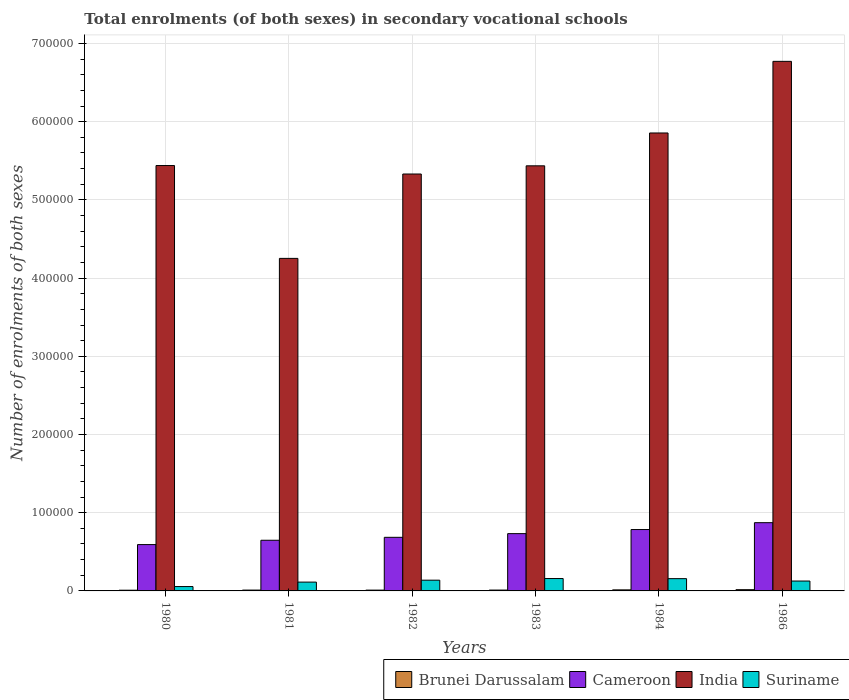How many different coloured bars are there?
Offer a very short reply. 4. Are the number of bars per tick equal to the number of legend labels?
Provide a succinct answer. Yes. How many bars are there on the 4th tick from the left?
Give a very brief answer. 4. How many bars are there on the 2nd tick from the right?
Give a very brief answer. 4. In how many cases, is the number of bars for a given year not equal to the number of legend labels?
Your answer should be very brief. 0. What is the number of enrolments in secondary schools in Suriname in 1980?
Your answer should be very brief. 5590. Across all years, what is the maximum number of enrolments in secondary schools in India?
Provide a succinct answer. 6.77e+05. Across all years, what is the minimum number of enrolments in secondary schools in India?
Provide a short and direct response. 4.25e+05. In which year was the number of enrolments in secondary schools in Suriname maximum?
Give a very brief answer. 1983. In which year was the number of enrolments in secondary schools in Suriname minimum?
Your answer should be compact. 1980. What is the total number of enrolments in secondary schools in India in the graph?
Your response must be concise. 3.31e+06. What is the difference between the number of enrolments in secondary schools in Cameroon in 1981 and that in 1986?
Offer a very short reply. -2.25e+04. What is the difference between the number of enrolments in secondary schools in Suriname in 1981 and the number of enrolments in secondary schools in Brunei Darussalam in 1980?
Provide a succinct answer. 1.04e+04. What is the average number of enrolments in secondary schools in Brunei Darussalam per year?
Make the answer very short. 1168.67. In the year 1982, what is the difference between the number of enrolments in secondary schools in Suriname and number of enrolments in secondary schools in Cameroon?
Keep it short and to the point. -5.48e+04. In how many years, is the number of enrolments in secondary schools in Cameroon greater than 680000?
Your answer should be compact. 0. What is the ratio of the number of enrolments in secondary schools in Suriname in 1980 to that in 1984?
Your response must be concise. 0.36. Is the number of enrolments in secondary schools in India in 1980 less than that in 1984?
Your answer should be very brief. Yes. What is the difference between the highest and the second highest number of enrolments in secondary schools in Cameroon?
Your response must be concise. 8786. What is the difference between the highest and the lowest number of enrolments in secondary schools in India?
Provide a succinct answer. 2.52e+05. In how many years, is the number of enrolments in secondary schools in Suriname greater than the average number of enrolments in secondary schools in Suriname taken over all years?
Offer a terse response. 4. What does the 4th bar from the left in 1981 represents?
Provide a short and direct response. Suriname. What does the 3rd bar from the right in 1981 represents?
Provide a short and direct response. Cameroon. Is it the case that in every year, the sum of the number of enrolments in secondary schools in Cameroon and number of enrolments in secondary schools in Brunei Darussalam is greater than the number of enrolments in secondary schools in India?
Your answer should be very brief. No. How many bars are there?
Offer a very short reply. 24. Are all the bars in the graph horizontal?
Offer a very short reply. No. How many years are there in the graph?
Give a very brief answer. 6. Are the values on the major ticks of Y-axis written in scientific E-notation?
Offer a terse response. No. Does the graph contain grids?
Give a very brief answer. Yes. Where does the legend appear in the graph?
Your answer should be compact. Bottom right. How many legend labels are there?
Offer a terse response. 4. What is the title of the graph?
Ensure brevity in your answer.  Total enrolments (of both sexes) in secondary vocational schools. Does "Seychelles" appear as one of the legend labels in the graph?
Your answer should be compact. No. What is the label or title of the Y-axis?
Make the answer very short. Number of enrolments of both sexes. What is the Number of enrolments of both sexes in Brunei Darussalam in 1980?
Keep it short and to the point. 909. What is the Number of enrolments of both sexes of Cameroon in 1980?
Your answer should be very brief. 5.92e+04. What is the Number of enrolments of both sexes in India in 1980?
Provide a short and direct response. 5.44e+05. What is the Number of enrolments of both sexes of Suriname in 1980?
Ensure brevity in your answer.  5590. What is the Number of enrolments of both sexes of Brunei Darussalam in 1981?
Offer a terse response. 1064. What is the Number of enrolments of both sexes of Cameroon in 1981?
Offer a very short reply. 6.48e+04. What is the Number of enrolments of both sexes in India in 1981?
Make the answer very short. 4.25e+05. What is the Number of enrolments of both sexes of Suriname in 1981?
Ensure brevity in your answer.  1.13e+04. What is the Number of enrolments of both sexes in Brunei Darussalam in 1982?
Provide a succinct answer. 1036. What is the Number of enrolments of both sexes in Cameroon in 1982?
Make the answer very short. 6.85e+04. What is the Number of enrolments of both sexes in India in 1982?
Provide a short and direct response. 5.33e+05. What is the Number of enrolments of both sexes of Suriname in 1982?
Give a very brief answer. 1.37e+04. What is the Number of enrolments of both sexes in Brunei Darussalam in 1983?
Provide a short and direct response. 1086. What is the Number of enrolments of both sexes of Cameroon in 1983?
Your response must be concise. 7.32e+04. What is the Number of enrolments of both sexes of India in 1983?
Your answer should be very brief. 5.44e+05. What is the Number of enrolments of both sexes in Suriname in 1983?
Offer a very short reply. 1.58e+04. What is the Number of enrolments of both sexes of Brunei Darussalam in 1984?
Make the answer very short. 1339. What is the Number of enrolments of both sexes of Cameroon in 1984?
Keep it short and to the point. 7.85e+04. What is the Number of enrolments of both sexes of India in 1984?
Give a very brief answer. 5.86e+05. What is the Number of enrolments of both sexes of Suriname in 1984?
Your answer should be compact. 1.57e+04. What is the Number of enrolments of both sexes of Brunei Darussalam in 1986?
Give a very brief answer. 1578. What is the Number of enrolments of both sexes in Cameroon in 1986?
Your response must be concise. 8.73e+04. What is the Number of enrolments of both sexes of India in 1986?
Keep it short and to the point. 6.77e+05. What is the Number of enrolments of both sexes of Suriname in 1986?
Provide a succinct answer. 1.26e+04. Across all years, what is the maximum Number of enrolments of both sexes in Brunei Darussalam?
Offer a very short reply. 1578. Across all years, what is the maximum Number of enrolments of both sexes of Cameroon?
Give a very brief answer. 8.73e+04. Across all years, what is the maximum Number of enrolments of both sexes of India?
Keep it short and to the point. 6.77e+05. Across all years, what is the maximum Number of enrolments of both sexes in Suriname?
Provide a succinct answer. 1.58e+04. Across all years, what is the minimum Number of enrolments of both sexes in Brunei Darussalam?
Provide a succinct answer. 909. Across all years, what is the minimum Number of enrolments of both sexes of Cameroon?
Provide a succinct answer. 5.92e+04. Across all years, what is the minimum Number of enrolments of both sexes of India?
Provide a short and direct response. 4.25e+05. Across all years, what is the minimum Number of enrolments of both sexes in Suriname?
Ensure brevity in your answer.  5590. What is the total Number of enrolments of both sexes of Brunei Darussalam in the graph?
Provide a short and direct response. 7012. What is the total Number of enrolments of both sexes in Cameroon in the graph?
Offer a terse response. 4.32e+05. What is the total Number of enrolments of both sexes in India in the graph?
Offer a terse response. 3.31e+06. What is the total Number of enrolments of both sexes in Suriname in the graph?
Provide a succinct answer. 7.48e+04. What is the difference between the Number of enrolments of both sexes in Brunei Darussalam in 1980 and that in 1981?
Your answer should be compact. -155. What is the difference between the Number of enrolments of both sexes in Cameroon in 1980 and that in 1981?
Make the answer very short. -5550. What is the difference between the Number of enrolments of both sexes of India in 1980 and that in 1981?
Keep it short and to the point. 1.19e+05. What is the difference between the Number of enrolments of both sexes in Suriname in 1980 and that in 1981?
Ensure brevity in your answer.  -5690. What is the difference between the Number of enrolments of both sexes in Brunei Darussalam in 1980 and that in 1982?
Offer a terse response. -127. What is the difference between the Number of enrolments of both sexes in Cameroon in 1980 and that in 1982?
Give a very brief answer. -9296. What is the difference between the Number of enrolments of both sexes in India in 1980 and that in 1982?
Make the answer very short. 1.08e+04. What is the difference between the Number of enrolments of both sexes in Suriname in 1980 and that in 1982?
Your response must be concise. -8151. What is the difference between the Number of enrolments of both sexes of Brunei Darussalam in 1980 and that in 1983?
Keep it short and to the point. -177. What is the difference between the Number of enrolments of both sexes of Cameroon in 1980 and that in 1983?
Offer a very short reply. -1.40e+04. What is the difference between the Number of enrolments of both sexes in India in 1980 and that in 1983?
Make the answer very short. 360. What is the difference between the Number of enrolments of both sexes of Suriname in 1980 and that in 1983?
Provide a short and direct response. -1.02e+04. What is the difference between the Number of enrolments of both sexes of Brunei Darussalam in 1980 and that in 1984?
Offer a terse response. -430. What is the difference between the Number of enrolments of both sexes of Cameroon in 1980 and that in 1984?
Make the answer very short. -1.92e+04. What is the difference between the Number of enrolments of both sexes in India in 1980 and that in 1984?
Offer a very short reply. -4.16e+04. What is the difference between the Number of enrolments of both sexes of Suriname in 1980 and that in 1984?
Your response must be concise. -1.01e+04. What is the difference between the Number of enrolments of both sexes in Brunei Darussalam in 1980 and that in 1986?
Provide a short and direct response. -669. What is the difference between the Number of enrolments of both sexes in Cameroon in 1980 and that in 1986?
Ensure brevity in your answer.  -2.80e+04. What is the difference between the Number of enrolments of both sexes in India in 1980 and that in 1986?
Offer a very short reply. -1.33e+05. What is the difference between the Number of enrolments of both sexes of Suriname in 1980 and that in 1986?
Offer a very short reply. -7044. What is the difference between the Number of enrolments of both sexes in Brunei Darussalam in 1981 and that in 1982?
Keep it short and to the point. 28. What is the difference between the Number of enrolments of both sexes of Cameroon in 1981 and that in 1982?
Your answer should be compact. -3746. What is the difference between the Number of enrolments of both sexes in India in 1981 and that in 1982?
Your answer should be compact. -1.08e+05. What is the difference between the Number of enrolments of both sexes of Suriname in 1981 and that in 1982?
Your answer should be compact. -2461. What is the difference between the Number of enrolments of both sexes of Brunei Darussalam in 1981 and that in 1983?
Keep it short and to the point. -22. What is the difference between the Number of enrolments of both sexes of Cameroon in 1981 and that in 1983?
Your answer should be very brief. -8456. What is the difference between the Number of enrolments of both sexes of India in 1981 and that in 1983?
Keep it short and to the point. -1.18e+05. What is the difference between the Number of enrolments of both sexes in Suriname in 1981 and that in 1983?
Ensure brevity in your answer.  -4551. What is the difference between the Number of enrolments of both sexes in Brunei Darussalam in 1981 and that in 1984?
Make the answer very short. -275. What is the difference between the Number of enrolments of both sexes of Cameroon in 1981 and that in 1984?
Your response must be concise. -1.37e+04. What is the difference between the Number of enrolments of both sexes in India in 1981 and that in 1984?
Give a very brief answer. -1.60e+05. What is the difference between the Number of enrolments of both sexes of Suriname in 1981 and that in 1984?
Keep it short and to the point. -4419. What is the difference between the Number of enrolments of both sexes of Brunei Darussalam in 1981 and that in 1986?
Keep it short and to the point. -514. What is the difference between the Number of enrolments of both sexes in Cameroon in 1981 and that in 1986?
Offer a terse response. -2.25e+04. What is the difference between the Number of enrolments of both sexes of India in 1981 and that in 1986?
Provide a short and direct response. -2.52e+05. What is the difference between the Number of enrolments of both sexes of Suriname in 1981 and that in 1986?
Keep it short and to the point. -1354. What is the difference between the Number of enrolments of both sexes in Brunei Darussalam in 1982 and that in 1983?
Ensure brevity in your answer.  -50. What is the difference between the Number of enrolments of both sexes in Cameroon in 1982 and that in 1983?
Your answer should be very brief. -4710. What is the difference between the Number of enrolments of both sexes of India in 1982 and that in 1983?
Ensure brevity in your answer.  -1.05e+04. What is the difference between the Number of enrolments of both sexes of Suriname in 1982 and that in 1983?
Provide a short and direct response. -2090. What is the difference between the Number of enrolments of both sexes in Brunei Darussalam in 1982 and that in 1984?
Make the answer very short. -303. What is the difference between the Number of enrolments of both sexes in Cameroon in 1982 and that in 1984?
Give a very brief answer. -9943. What is the difference between the Number of enrolments of both sexes of India in 1982 and that in 1984?
Provide a short and direct response. -5.25e+04. What is the difference between the Number of enrolments of both sexes in Suriname in 1982 and that in 1984?
Offer a terse response. -1958. What is the difference between the Number of enrolments of both sexes of Brunei Darussalam in 1982 and that in 1986?
Give a very brief answer. -542. What is the difference between the Number of enrolments of both sexes of Cameroon in 1982 and that in 1986?
Give a very brief answer. -1.87e+04. What is the difference between the Number of enrolments of both sexes in India in 1982 and that in 1986?
Offer a very short reply. -1.44e+05. What is the difference between the Number of enrolments of both sexes in Suriname in 1982 and that in 1986?
Ensure brevity in your answer.  1107. What is the difference between the Number of enrolments of both sexes in Brunei Darussalam in 1983 and that in 1984?
Provide a succinct answer. -253. What is the difference between the Number of enrolments of both sexes of Cameroon in 1983 and that in 1984?
Offer a terse response. -5233. What is the difference between the Number of enrolments of both sexes of India in 1983 and that in 1984?
Offer a very short reply. -4.20e+04. What is the difference between the Number of enrolments of both sexes of Suriname in 1983 and that in 1984?
Ensure brevity in your answer.  132. What is the difference between the Number of enrolments of both sexes in Brunei Darussalam in 1983 and that in 1986?
Your response must be concise. -492. What is the difference between the Number of enrolments of both sexes in Cameroon in 1983 and that in 1986?
Make the answer very short. -1.40e+04. What is the difference between the Number of enrolments of both sexes in India in 1983 and that in 1986?
Offer a terse response. -1.34e+05. What is the difference between the Number of enrolments of both sexes of Suriname in 1983 and that in 1986?
Make the answer very short. 3197. What is the difference between the Number of enrolments of both sexes of Brunei Darussalam in 1984 and that in 1986?
Provide a succinct answer. -239. What is the difference between the Number of enrolments of both sexes in Cameroon in 1984 and that in 1986?
Your answer should be very brief. -8786. What is the difference between the Number of enrolments of both sexes in India in 1984 and that in 1986?
Provide a succinct answer. -9.16e+04. What is the difference between the Number of enrolments of both sexes in Suriname in 1984 and that in 1986?
Provide a succinct answer. 3065. What is the difference between the Number of enrolments of both sexes of Brunei Darussalam in 1980 and the Number of enrolments of both sexes of Cameroon in 1981?
Keep it short and to the point. -6.39e+04. What is the difference between the Number of enrolments of both sexes of Brunei Darussalam in 1980 and the Number of enrolments of both sexes of India in 1981?
Provide a succinct answer. -4.24e+05. What is the difference between the Number of enrolments of both sexes of Brunei Darussalam in 1980 and the Number of enrolments of both sexes of Suriname in 1981?
Keep it short and to the point. -1.04e+04. What is the difference between the Number of enrolments of both sexes in Cameroon in 1980 and the Number of enrolments of both sexes in India in 1981?
Provide a short and direct response. -3.66e+05. What is the difference between the Number of enrolments of both sexes of Cameroon in 1980 and the Number of enrolments of both sexes of Suriname in 1981?
Your response must be concise. 4.80e+04. What is the difference between the Number of enrolments of both sexes in India in 1980 and the Number of enrolments of both sexes in Suriname in 1981?
Offer a very short reply. 5.33e+05. What is the difference between the Number of enrolments of both sexes in Brunei Darussalam in 1980 and the Number of enrolments of both sexes in Cameroon in 1982?
Provide a short and direct response. -6.76e+04. What is the difference between the Number of enrolments of both sexes of Brunei Darussalam in 1980 and the Number of enrolments of both sexes of India in 1982?
Make the answer very short. -5.32e+05. What is the difference between the Number of enrolments of both sexes in Brunei Darussalam in 1980 and the Number of enrolments of both sexes in Suriname in 1982?
Ensure brevity in your answer.  -1.28e+04. What is the difference between the Number of enrolments of both sexes of Cameroon in 1980 and the Number of enrolments of both sexes of India in 1982?
Ensure brevity in your answer.  -4.74e+05. What is the difference between the Number of enrolments of both sexes of Cameroon in 1980 and the Number of enrolments of both sexes of Suriname in 1982?
Keep it short and to the point. 4.55e+04. What is the difference between the Number of enrolments of both sexes in India in 1980 and the Number of enrolments of both sexes in Suriname in 1982?
Give a very brief answer. 5.30e+05. What is the difference between the Number of enrolments of both sexes of Brunei Darussalam in 1980 and the Number of enrolments of both sexes of Cameroon in 1983?
Make the answer very short. -7.23e+04. What is the difference between the Number of enrolments of both sexes in Brunei Darussalam in 1980 and the Number of enrolments of both sexes in India in 1983?
Offer a terse response. -5.43e+05. What is the difference between the Number of enrolments of both sexes of Brunei Darussalam in 1980 and the Number of enrolments of both sexes of Suriname in 1983?
Provide a succinct answer. -1.49e+04. What is the difference between the Number of enrolments of both sexes of Cameroon in 1980 and the Number of enrolments of both sexes of India in 1983?
Your response must be concise. -4.84e+05. What is the difference between the Number of enrolments of both sexes of Cameroon in 1980 and the Number of enrolments of both sexes of Suriname in 1983?
Provide a short and direct response. 4.34e+04. What is the difference between the Number of enrolments of both sexes of India in 1980 and the Number of enrolments of both sexes of Suriname in 1983?
Offer a terse response. 5.28e+05. What is the difference between the Number of enrolments of both sexes of Brunei Darussalam in 1980 and the Number of enrolments of both sexes of Cameroon in 1984?
Give a very brief answer. -7.76e+04. What is the difference between the Number of enrolments of both sexes of Brunei Darussalam in 1980 and the Number of enrolments of both sexes of India in 1984?
Provide a succinct answer. -5.85e+05. What is the difference between the Number of enrolments of both sexes in Brunei Darussalam in 1980 and the Number of enrolments of both sexes in Suriname in 1984?
Provide a short and direct response. -1.48e+04. What is the difference between the Number of enrolments of both sexes in Cameroon in 1980 and the Number of enrolments of both sexes in India in 1984?
Give a very brief answer. -5.26e+05. What is the difference between the Number of enrolments of both sexes of Cameroon in 1980 and the Number of enrolments of both sexes of Suriname in 1984?
Keep it short and to the point. 4.35e+04. What is the difference between the Number of enrolments of both sexes in India in 1980 and the Number of enrolments of both sexes in Suriname in 1984?
Make the answer very short. 5.28e+05. What is the difference between the Number of enrolments of both sexes of Brunei Darussalam in 1980 and the Number of enrolments of both sexes of Cameroon in 1986?
Your answer should be compact. -8.64e+04. What is the difference between the Number of enrolments of both sexes of Brunei Darussalam in 1980 and the Number of enrolments of both sexes of India in 1986?
Your answer should be very brief. -6.76e+05. What is the difference between the Number of enrolments of both sexes of Brunei Darussalam in 1980 and the Number of enrolments of both sexes of Suriname in 1986?
Your response must be concise. -1.17e+04. What is the difference between the Number of enrolments of both sexes of Cameroon in 1980 and the Number of enrolments of both sexes of India in 1986?
Provide a succinct answer. -6.18e+05. What is the difference between the Number of enrolments of both sexes in Cameroon in 1980 and the Number of enrolments of both sexes in Suriname in 1986?
Give a very brief answer. 4.66e+04. What is the difference between the Number of enrolments of both sexes in India in 1980 and the Number of enrolments of both sexes in Suriname in 1986?
Your response must be concise. 5.31e+05. What is the difference between the Number of enrolments of both sexes in Brunei Darussalam in 1981 and the Number of enrolments of both sexes in Cameroon in 1982?
Provide a short and direct response. -6.75e+04. What is the difference between the Number of enrolments of both sexes in Brunei Darussalam in 1981 and the Number of enrolments of both sexes in India in 1982?
Ensure brevity in your answer.  -5.32e+05. What is the difference between the Number of enrolments of both sexes of Brunei Darussalam in 1981 and the Number of enrolments of both sexes of Suriname in 1982?
Keep it short and to the point. -1.27e+04. What is the difference between the Number of enrolments of both sexes of Cameroon in 1981 and the Number of enrolments of both sexes of India in 1982?
Offer a terse response. -4.68e+05. What is the difference between the Number of enrolments of both sexes in Cameroon in 1981 and the Number of enrolments of both sexes in Suriname in 1982?
Ensure brevity in your answer.  5.11e+04. What is the difference between the Number of enrolments of both sexes in India in 1981 and the Number of enrolments of both sexes in Suriname in 1982?
Your answer should be compact. 4.11e+05. What is the difference between the Number of enrolments of both sexes in Brunei Darussalam in 1981 and the Number of enrolments of both sexes in Cameroon in 1983?
Offer a terse response. -7.22e+04. What is the difference between the Number of enrolments of both sexes in Brunei Darussalam in 1981 and the Number of enrolments of both sexes in India in 1983?
Your answer should be very brief. -5.43e+05. What is the difference between the Number of enrolments of both sexes in Brunei Darussalam in 1981 and the Number of enrolments of both sexes in Suriname in 1983?
Provide a succinct answer. -1.48e+04. What is the difference between the Number of enrolments of both sexes of Cameroon in 1981 and the Number of enrolments of both sexes of India in 1983?
Your answer should be very brief. -4.79e+05. What is the difference between the Number of enrolments of both sexes in Cameroon in 1981 and the Number of enrolments of both sexes in Suriname in 1983?
Make the answer very short. 4.90e+04. What is the difference between the Number of enrolments of both sexes in India in 1981 and the Number of enrolments of both sexes in Suriname in 1983?
Ensure brevity in your answer.  4.09e+05. What is the difference between the Number of enrolments of both sexes in Brunei Darussalam in 1981 and the Number of enrolments of both sexes in Cameroon in 1984?
Offer a terse response. -7.74e+04. What is the difference between the Number of enrolments of both sexes in Brunei Darussalam in 1981 and the Number of enrolments of both sexes in India in 1984?
Your response must be concise. -5.85e+05. What is the difference between the Number of enrolments of both sexes in Brunei Darussalam in 1981 and the Number of enrolments of both sexes in Suriname in 1984?
Offer a terse response. -1.46e+04. What is the difference between the Number of enrolments of both sexes in Cameroon in 1981 and the Number of enrolments of both sexes in India in 1984?
Your response must be concise. -5.21e+05. What is the difference between the Number of enrolments of both sexes of Cameroon in 1981 and the Number of enrolments of both sexes of Suriname in 1984?
Your answer should be very brief. 4.91e+04. What is the difference between the Number of enrolments of both sexes of India in 1981 and the Number of enrolments of both sexes of Suriname in 1984?
Your response must be concise. 4.10e+05. What is the difference between the Number of enrolments of both sexes of Brunei Darussalam in 1981 and the Number of enrolments of both sexes of Cameroon in 1986?
Keep it short and to the point. -8.62e+04. What is the difference between the Number of enrolments of both sexes of Brunei Darussalam in 1981 and the Number of enrolments of both sexes of India in 1986?
Keep it short and to the point. -6.76e+05. What is the difference between the Number of enrolments of both sexes of Brunei Darussalam in 1981 and the Number of enrolments of both sexes of Suriname in 1986?
Make the answer very short. -1.16e+04. What is the difference between the Number of enrolments of both sexes in Cameroon in 1981 and the Number of enrolments of both sexes in India in 1986?
Give a very brief answer. -6.12e+05. What is the difference between the Number of enrolments of both sexes in Cameroon in 1981 and the Number of enrolments of both sexes in Suriname in 1986?
Your response must be concise. 5.22e+04. What is the difference between the Number of enrolments of both sexes in India in 1981 and the Number of enrolments of both sexes in Suriname in 1986?
Make the answer very short. 4.13e+05. What is the difference between the Number of enrolments of both sexes of Brunei Darussalam in 1982 and the Number of enrolments of both sexes of Cameroon in 1983?
Keep it short and to the point. -7.22e+04. What is the difference between the Number of enrolments of both sexes in Brunei Darussalam in 1982 and the Number of enrolments of both sexes in India in 1983?
Keep it short and to the point. -5.43e+05. What is the difference between the Number of enrolments of both sexes of Brunei Darussalam in 1982 and the Number of enrolments of both sexes of Suriname in 1983?
Provide a short and direct response. -1.48e+04. What is the difference between the Number of enrolments of both sexes in Cameroon in 1982 and the Number of enrolments of both sexes in India in 1983?
Keep it short and to the point. -4.75e+05. What is the difference between the Number of enrolments of both sexes in Cameroon in 1982 and the Number of enrolments of both sexes in Suriname in 1983?
Provide a succinct answer. 5.27e+04. What is the difference between the Number of enrolments of both sexes of India in 1982 and the Number of enrolments of both sexes of Suriname in 1983?
Give a very brief answer. 5.17e+05. What is the difference between the Number of enrolments of both sexes of Brunei Darussalam in 1982 and the Number of enrolments of both sexes of Cameroon in 1984?
Keep it short and to the point. -7.74e+04. What is the difference between the Number of enrolments of both sexes in Brunei Darussalam in 1982 and the Number of enrolments of both sexes in India in 1984?
Keep it short and to the point. -5.85e+05. What is the difference between the Number of enrolments of both sexes in Brunei Darussalam in 1982 and the Number of enrolments of both sexes in Suriname in 1984?
Keep it short and to the point. -1.47e+04. What is the difference between the Number of enrolments of both sexes of Cameroon in 1982 and the Number of enrolments of both sexes of India in 1984?
Offer a terse response. -5.17e+05. What is the difference between the Number of enrolments of both sexes in Cameroon in 1982 and the Number of enrolments of both sexes in Suriname in 1984?
Make the answer very short. 5.28e+04. What is the difference between the Number of enrolments of both sexes of India in 1982 and the Number of enrolments of both sexes of Suriname in 1984?
Offer a terse response. 5.17e+05. What is the difference between the Number of enrolments of both sexes in Brunei Darussalam in 1982 and the Number of enrolments of both sexes in Cameroon in 1986?
Your response must be concise. -8.62e+04. What is the difference between the Number of enrolments of both sexes in Brunei Darussalam in 1982 and the Number of enrolments of both sexes in India in 1986?
Make the answer very short. -6.76e+05. What is the difference between the Number of enrolments of both sexes in Brunei Darussalam in 1982 and the Number of enrolments of both sexes in Suriname in 1986?
Your answer should be compact. -1.16e+04. What is the difference between the Number of enrolments of both sexes in Cameroon in 1982 and the Number of enrolments of both sexes in India in 1986?
Offer a terse response. -6.09e+05. What is the difference between the Number of enrolments of both sexes of Cameroon in 1982 and the Number of enrolments of both sexes of Suriname in 1986?
Offer a very short reply. 5.59e+04. What is the difference between the Number of enrolments of both sexes of India in 1982 and the Number of enrolments of both sexes of Suriname in 1986?
Your answer should be very brief. 5.20e+05. What is the difference between the Number of enrolments of both sexes of Brunei Darussalam in 1983 and the Number of enrolments of both sexes of Cameroon in 1984?
Your answer should be very brief. -7.74e+04. What is the difference between the Number of enrolments of both sexes in Brunei Darussalam in 1983 and the Number of enrolments of both sexes in India in 1984?
Provide a succinct answer. -5.84e+05. What is the difference between the Number of enrolments of both sexes of Brunei Darussalam in 1983 and the Number of enrolments of both sexes of Suriname in 1984?
Your answer should be very brief. -1.46e+04. What is the difference between the Number of enrolments of both sexes in Cameroon in 1983 and the Number of enrolments of both sexes in India in 1984?
Ensure brevity in your answer.  -5.12e+05. What is the difference between the Number of enrolments of both sexes in Cameroon in 1983 and the Number of enrolments of both sexes in Suriname in 1984?
Provide a short and direct response. 5.75e+04. What is the difference between the Number of enrolments of both sexes of India in 1983 and the Number of enrolments of both sexes of Suriname in 1984?
Keep it short and to the point. 5.28e+05. What is the difference between the Number of enrolments of both sexes of Brunei Darussalam in 1983 and the Number of enrolments of both sexes of Cameroon in 1986?
Offer a terse response. -8.62e+04. What is the difference between the Number of enrolments of both sexes in Brunei Darussalam in 1983 and the Number of enrolments of both sexes in India in 1986?
Give a very brief answer. -6.76e+05. What is the difference between the Number of enrolments of both sexes of Brunei Darussalam in 1983 and the Number of enrolments of both sexes of Suriname in 1986?
Keep it short and to the point. -1.15e+04. What is the difference between the Number of enrolments of both sexes of Cameroon in 1983 and the Number of enrolments of both sexes of India in 1986?
Ensure brevity in your answer.  -6.04e+05. What is the difference between the Number of enrolments of both sexes in Cameroon in 1983 and the Number of enrolments of both sexes in Suriname in 1986?
Offer a terse response. 6.06e+04. What is the difference between the Number of enrolments of both sexes in India in 1983 and the Number of enrolments of both sexes in Suriname in 1986?
Your response must be concise. 5.31e+05. What is the difference between the Number of enrolments of both sexes of Brunei Darussalam in 1984 and the Number of enrolments of both sexes of Cameroon in 1986?
Your response must be concise. -8.59e+04. What is the difference between the Number of enrolments of both sexes of Brunei Darussalam in 1984 and the Number of enrolments of both sexes of India in 1986?
Keep it short and to the point. -6.76e+05. What is the difference between the Number of enrolments of both sexes in Brunei Darussalam in 1984 and the Number of enrolments of both sexes in Suriname in 1986?
Ensure brevity in your answer.  -1.13e+04. What is the difference between the Number of enrolments of both sexes of Cameroon in 1984 and the Number of enrolments of both sexes of India in 1986?
Provide a short and direct response. -5.99e+05. What is the difference between the Number of enrolments of both sexes of Cameroon in 1984 and the Number of enrolments of both sexes of Suriname in 1986?
Ensure brevity in your answer.  6.58e+04. What is the difference between the Number of enrolments of both sexes in India in 1984 and the Number of enrolments of both sexes in Suriname in 1986?
Your response must be concise. 5.73e+05. What is the average Number of enrolments of both sexes of Brunei Darussalam per year?
Offer a terse response. 1168.67. What is the average Number of enrolments of both sexes in Cameroon per year?
Give a very brief answer. 7.19e+04. What is the average Number of enrolments of both sexes of India per year?
Your response must be concise. 5.51e+05. What is the average Number of enrolments of both sexes in Suriname per year?
Ensure brevity in your answer.  1.25e+04. In the year 1980, what is the difference between the Number of enrolments of both sexes in Brunei Darussalam and Number of enrolments of both sexes in Cameroon?
Keep it short and to the point. -5.83e+04. In the year 1980, what is the difference between the Number of enrolments of both sexes in Brunei Darussalam and Number of enrolments of both sexes in India?
Give a very brief answer. -5.43e+05. In the year 1980, what is the difference between the Number of enrolments of both sexes of Brunei Darussalam and Number of enrolments of both sexes of Suriname?
Make the answer very short. -4681. In the year 1980, what is the difference between the Number of enrolments of both sexes in Cameroon and Number of enrolments of both sexes in India?
Offer a terse response. -4.85e+05. In the year 1980, what is the difference between the Number of enrolments of both sexes in Cameroon and Number of enrolments of both sexes in Suriname?
Your answer should be very brief. 5.37e+04. In the year 1980, what is the difference between the Number of enrolments of both sexes in India and Number of enrolments of both sexes in Suriname?
Offer a very short reply. 5.38e+05. In the year 1981, what is the difference between the Number of enrolments of both sexes of Brunei Darussalam and Number of enrolments of both sexes of Cameroon?
Offer a very short reply. -6.37e+04. In the year 1981, what is the difference between the Number of enrolments of both sexes in Brunei Darussalam and Number of enrolments of both sexes in India?
Provide a succinct answer. -4.24e+05. In the year 1981, what is the difference between the Number of enrolments of both sexes of Brunei Darussalam and Number of enrolments of both sexes of Suriname?
Your response must be concise. -1.02e+04. In the year 1981, what is the difference between the Number of enrolments of both sexes in Cameroon and Number of enrolments of both sexes in India?
Provide a short and direct response. -3.60e+05. In the year 1981, what is the difference between the Number of enrolments of both sexes in Cameroon and Number of enrolments of both sexes in Suriname?
Keep it short and to the point. 5.35e+04. In the year 1981, what is the difference between the Number of enrolments of both sexes of India and Number of enrolments of both sexes of Suriname?
Your response must be concise. 4.14e+05. In the year 1982, what is the difference between the Number of enrolments of both sexes of Brunei Darussalam and Number of enrolments of both sexes of Cameroon?
Keep it short and to the point. -6.75e+04. In the year 1982, what is the difference between the Number of enrolments of both sexes in Brunei Darussalam and Number of enrolments of both sexes in India?
Your answer should be compact. -5.32e+05. In the year 1982, what is the difference between the Number of enrolments of both sexes in Brunei Darussalam and Number of enrolments of both sexes in Suriname?
Ensure brevity in your answer.  -1.27e+04. In the year 1982, what is the difference between the Number of enrolments of both sexes in Cameroon and Number of enrolments of both sexes in India?
Make the answer very short. -4.65e+05. In the year 1982, what is the difference between the Number of enrolments of both sexes in Cameroon and Number of enrolments of both sexes in Suriname?
Your response must be concise. 5.48e+04. In the year 1982, what is the difference between the Number of enrolments of both sexes of India and Number of enrolments of both sexes of Suriname?
Your answer should be compact. 5.19e+05. In the year 1983, what is the difference between the Number of enrolments of both sexes of Brunei Darussalam and Number of enrolments of both sexes of Cameroon?
Your answer should be very brief. -7.22e+04. In the year 1983, what is the difference between the Number of enrolments of both sexes of Brunei Darussalam and Number of enrolments of both sexes of India?
Your answer should be very brief. -5.43e+05. In the year 1983, what is the difference between the Number of enrolments of both sexes in Brunei Darussalam and Number of enrolments of both sexes in Suriname?
Keep it short and to the point. -1.47e+04. In the year 1983, what is the difference between the Number of enrolments of both sexes of Cameroon and Number of enrolments of both sexes of India?
Offer a very short reply. -4.70e+05. In the year 1983, what is the difference between the Number of enrolments of both sexes in Cameroon and Number of enrolments of both sexes in Suriname?
Your answer should be compact. 5.74e+04. In the year 1983, what is the difference between the Number of enrolments of both sexes in India and Number of enrolments of both sexes in Suriname?
Offer a very short reply. 5.28e+05. In the year 1984, what is the difference between the Number of enrolments of both sexes in Brunei Darussalam and Number of enrolments of both sexes in Cameroon?
Offer a terse response. -7.71e+04. In the year 1984, what is the difference between the Number of enrolments of both sexes in Brunei Darussalam and Number of enrolments of both sexes in India?
Provide a short and direct response. -5.84e+05. In the year 1984, what is the difference between the Number of enrolments of both sexes of Brunei Darussalam and Number of enrolments of both sexes of Suriname?
Make the answer very short. -1.44e+04. In the year 1984, what is the difference between the Number of enrolments of both sexes of Cameroon and Number of enrolments of both sexes of India?
Your response must be concise. -5.07e+05. In the year 1984, what is the difference between the Number of enrolments of both sexes in Cameroon and Number of enrolments of both sexes in Suriname?
Make the answer very short. 6.28e+04. In the year 1984, what is the difference between the Number of enrolments of both sexes in India and Number of enrolments of both sexes in Suriname?
Give a very brief answer. 5.70e+05. In the year 1986, what is the difference between the Number of enrolments of both sexes in Brunei Darussalam and Number of enrolments of both sexes in Cameroon?
Provide a short and direct response. -8.57e+04. In the year 1986, what is the difference between the Number of enrolments of both sexes in Brunei Darussalam and Number of enrolments of both sexes in India?
Offer a very short reply. -6.76e+05. In the year 1986, what is the difference between the Number of enrolments of both sexes of Brunei Darussalam and Number of enrolments of both sexes of Suriname?
Give a very brief answer. -1.11e+04. In the year 1986, what is the difference between the Number of enrolments of both sexes in Cameroon and Number of enrolments of both sexes in India?
Ensure brevity in your answer.  -5.90e+05. In the year 1986, what is the difference between the Number of enrolments of both sexes in Cameroon and Number of enrolments of both sexes in Suriname?
Your response must be concise. 7.46e+04. In the year 1986, what is the difference between the Number of enrolments of both sexes in India and Number of enrolments of both sexes in Suriname?
Your answer should be compact. 6.65e+05. What is the ratio of the Number of enrolments of both sexes in Brunei Darussalam in 1980 to that in 1981?
Offer a terse response. 0.85. What is the ratio of the Number of enrolments of both sexes in Cameroon in 1980 to that in 1981?
Your answer should be compact. 0.91. What is the ratio of the Number of enrolments of both sexes in India in 1980 to that in 1981?
Make the answer very short. 1.28. What is the ratio of the Number of enrolments of both sexes in Suriname in 1980 to that in 1981?
Offer a terse response. 0.5. What is the ratio of the Number of enrolments of both sexes of Brunei Darussalam in 1980 to that in 1982?
Offer a very short reply. 0.88. What is the ratio of the Number of enrolments of both sexes of Cameroon in 1980 to that in 1982?
Give a very brief answer. 0.86. What is the ratio of the Number of enrolments of both sexes of India in 1980 to that in 1982?
Provide a succinct answer. 1.02. What is the ratio of the Number of enrolments of both sexes of Suriname in 1980 to that in 1982?
Your response must be concise. 0.41. What is the ratio of the Number of enrolments of both sexes of Brunei Darussalam in 1980 to that in 1983?
Provide a short and direct response. 0.84. What is the ratio of the Number of enrolments of both sexes in Cameroon in 1980 to that in 1983?
Give a very brief answer. 0.81. What is the ratio of the Number of enrolments of both sexes in India in 1980 to that in 1983?
Your answer should be compact. 1. What is the ratio of the Number of enrolments of both sexes in Suriname in 1980 to that in 1983?
Offer a very short reply. 0.35. What is the ratio of the Number of enrolments of both sexes of Brunei Darussalam in 1980 to that in 1984?
Your response must be concise. 0.68. What is the ratio of the Number of enrolments of both sexes in Cameroon in 1980 to that in 1984?
Your answer should be compact. 0.75. What is the ratio of the Number of enrolments of both sexes of India in 1980 to that in 1984?
Provide a short and direct response. 0.93. What is the ratio of the Number of enrolments of both sexes in Suriname in 1980 to that in 1984?
Make the answer very short. 0.36. What is the ratio of the Number of enrolments of both sexes of Brunei Darussalam in 1980 to that in 1986?
Offer a terse response. 0.58. What is the ratio of the Number of enrolments of both sexes of Cameroon in 1980 to that in 1986?
Offer a terse response. 0.68. What is the ratio of the Number of enrolments of both sexes of India in 1980 to that in 1986?
Your answer should be very brief. 0.8. What is the ratio of the Number of enrolments of both sexes of Suriname in 1980 to that in 1986?
Your answer should be very brief. 0.44. What is the ratio of the Number of enrolments of both sexes in Brunei Darussalam in 1981 to that in 1982?
Offer a terse response. 1.03. What is the ratio of the Number of enrolments of both sexes of Cameroon in 1981 to that in 1982?
Make the answer very short. 0.95. What is the ratio of the Number of enrolments of both sexes of India in 1981 to that in 1982?
Keep it short and to the point. 0.8. What is the ratio of the Number of enrolments of both sexes of Suriname in 1981 to that in 1982?
Ensure brevity in your answer.  0.82. What is the ratio of the Number of enrolments of both sexes of Brunei Darussalam in 1981 to that in 1983?
Offer a very short reply. 0.98. What is the ratio of the Number of enrolments of both sexes of Cameroon in 1981 to that in 1983?
Ensure brevity in your answer.  0.88. What is the ratio of the Number of enrolments of both sexes in India in 1981 to that in 1983?
Give a very brief answer. 0.78. What is the ratio of the Number of enrolments of both sexes of Suriname in 1981 to that in 1983?
Make the answer very short. 0.71. What is the ratio of the Number of enrolments of both sexes of Brunei Darussalam in 1981 to that in 1984?
Your response must be concise. 0.79. What is the ratio of the Number of enrolments of both sexes in Cameroon in 1981 to that in 1984?
Keep it short and to the point. 0.83. What is the ratio of the Number of enrolments of both sexes in India in 1981 to that in 1984?
Provide a succinct answer. 0.73. What is the ratio of the Number of enrolments of both sexes of Suriname in 1981 to that in 1984?
Provide a succinct answer. 0.72. What is the ratio of the Number of enrolments of both sexes in Brunei Darussalam in 1981 to that in 1986?
Ensure brevity in your answer.  0.67. What is the ratio of the Number of enrolments of both sexes of Cameroon in 1981 to that in 1986?
Keep it short and to the point. 0.74. What is the ratio of the Number of enrolments of both sexes in India in 1981 to that in 1986?
Keep it short and to the point. 0.63. What is the ratio of the Number of enrolments of both sexes in Suriname in 1981 to that in 1986?
Provide a short and direct response. 0.89. What is the ratio of the Number of enrolments of both sexes in Brunei Darussalam in 1982 to that in 1983?
Offer a very short reply. 0.95. What is the ratio of the Number of enrolments of both sexes in Cameroon in 1982 to that in 1983?
Your response must be concise. 0.94. What is the ratio of the Number of enrolments of both sexes of India in 1982 to that in 1983?
Give a very brief answer. 0.98. What is the ratio of the Number of enrolments of both sexes in Suriname in 1982 to that in 1983?
Keep it short and to the point. 0.87. What is the ratio of the Number of enrolments of both sexes of Brunei Darussalam in 1982 to that in 1984?
Your response must be concise. 0.77. What is the ratio of the Number of enrolments of both sexes of Cameroon in 1982 to that in 1984?
Your response must be concise. 0.87. What is the ratio of the Number of enrolments of both sexes in India in 1982 to that in 1984?
Keep it short and to the point. 0.91. What is the ratio of the Number of enrolments of both sexes in Suriname in 1982 to that in 1984?
Provide a short and direct response. 0.88. What is the ratio of the Number of enrolments of both sexes in Brunei Darussalam in 1982 to that in 1986?
Your answer should be compact. 0.66. What is the ratio of the Number of enrolments of both sexes of Cameroon in 1982 to that in 1986?
Your response must be concise. 0.79. What is the ratio of the Number of enrolments of both sexes in India in 1982 to that in 1986?
Your answer should be very brief. 0.79. What is the ratio of the Number of enrolments of both sexes of Suriname in 1982 to that in 1986?
Your answer should be very brief. 1.09. What is the ratio of the Number of enrolments of both sexes of Brunei Darussalam in 1983 to that in 1984?
Your answer should be very brief. 0.81. What is the ratio of the Number of enrolments of both sexes of Cameroon in 1983 to that in 1984?
Offer a terse response. 0.93. What is the ratio of the Number of enrolments of both sexes in India in 1983 to that in 1984?
Your response must be concise. 0.93. What is the ratio of the Number of enrolments of both sexes of Suriname in 1983 to that in 1984?
Your answer should be compact. 1.01. What is the ratio of the Number of enrolments of both sexes in Brunei Darussalam in 1983 to that in 1986?
Provide a succinct answer. 0.69. What is the ratio of the Number of enrolments of both sexes in Cameroon in 1983 to that in 1986?
Give a very brief answer. 0.84. What is the ratio of the Number of enrolments of both sexes of India in 1983 to that in 1986?
Provide a short and direct response. 0.8. What is the ratio of the Number of enrolments of both sexes in Suriname in 1983 to that in 1986?
Give a very brief answer. 1.25. What is the ratio of the Number of enrolments of both sexes in Brunei Darussalam in 1984 to that in 1986?
Offer a very short reply. 0.85. What is the ratio of the Number of enrolments of both sexes of Cameroon in 1984 to that in 1986?
Give a very brief answer. 0.9. What is the ratio of the Number of enrolments of both sexes in India in 1984 to that in 1986?
Give a very brief answer. 0.86. What is the ratio of the Number of enrolments of both sexes of Suriname in 1984 to that in 1986?
Your response must be concise. 1.24. What is the difference between the highest and the second highest Number of enrolments of both sexes of Brunei Darussalam?
Ensure brevity in your answer.  239. What is the difference between the highest and the second highest Number of enrolments of both sexes in Cameroon?
Provide a short and direct response. 8786. What is the difference between the highest and the second highest Number of enrolments of both sexes of India?
Provide a succinct answer. 9.16e+04. What is the difference between the highest and the second highest Number of enrolments of both sexes of Suriname?
Provide a succinct answer. 132. What is the difference between the highest and the lowest Number of enrolments of both sexes in Brunei Darussalam?
Your answer should be very brief. 669. What is the difference between the highest and the lowest Number of enrolments of both sexes in Cameroon?
Offer a terse response. 2.80e+04. What is the difference between the highest and the lowest Number of enrolments of both sexes of India?
Your response must be concise. 2.52e+05. What is the difference between the highest and the lowest Number of enrolments of both sexes in Suriname?
Your answer should be compact. 1.02e+04. 